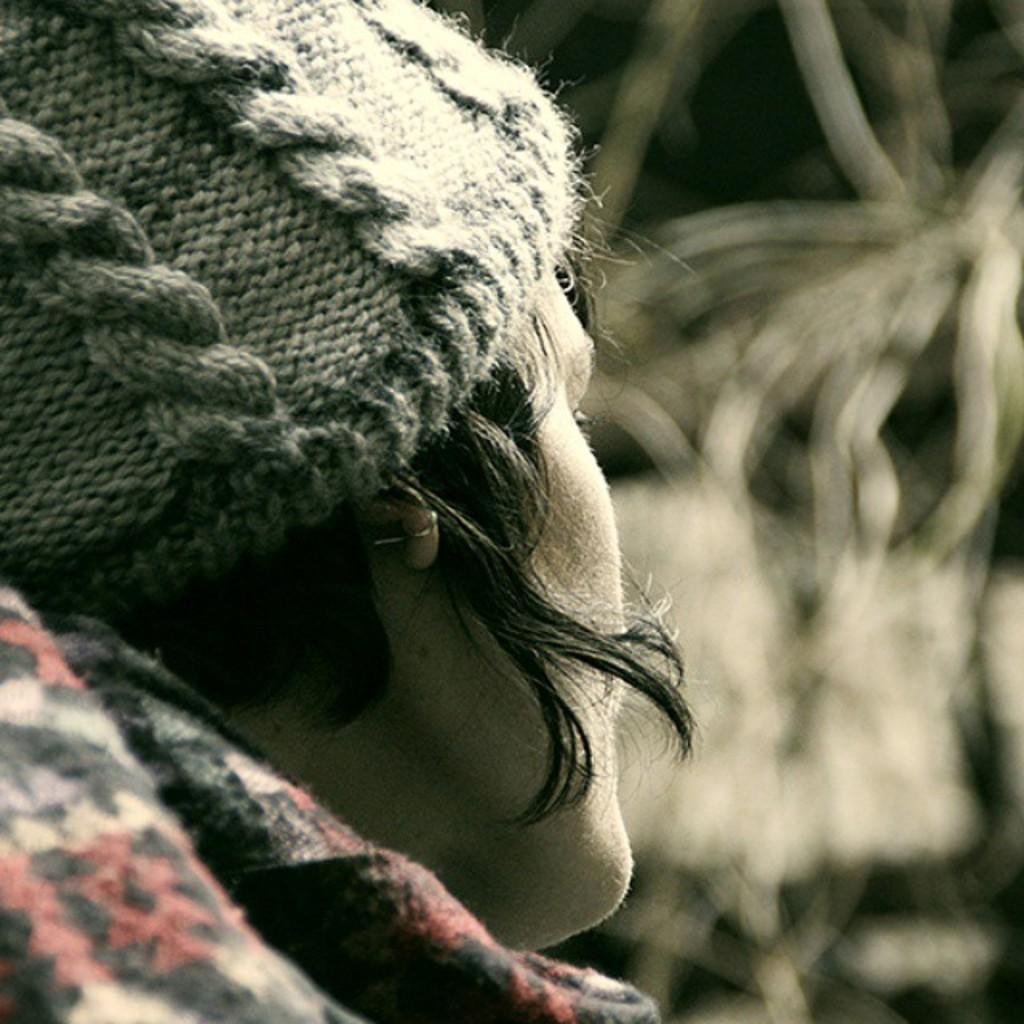Who or what is the main subject in the image? There is a person in the image. What is the person wearing on their head? The person is wearing a cap. What type of clothing is the person wearing on their upper body? The person is wearing a coat. Can you describe the background of the image? The background of the image is blurry. What direction is the rabbit facing in the image? There is no rabbit present in the image. What season is depicted in the image? The provided facts do not mention any season, so it cannot be determined from the image. 